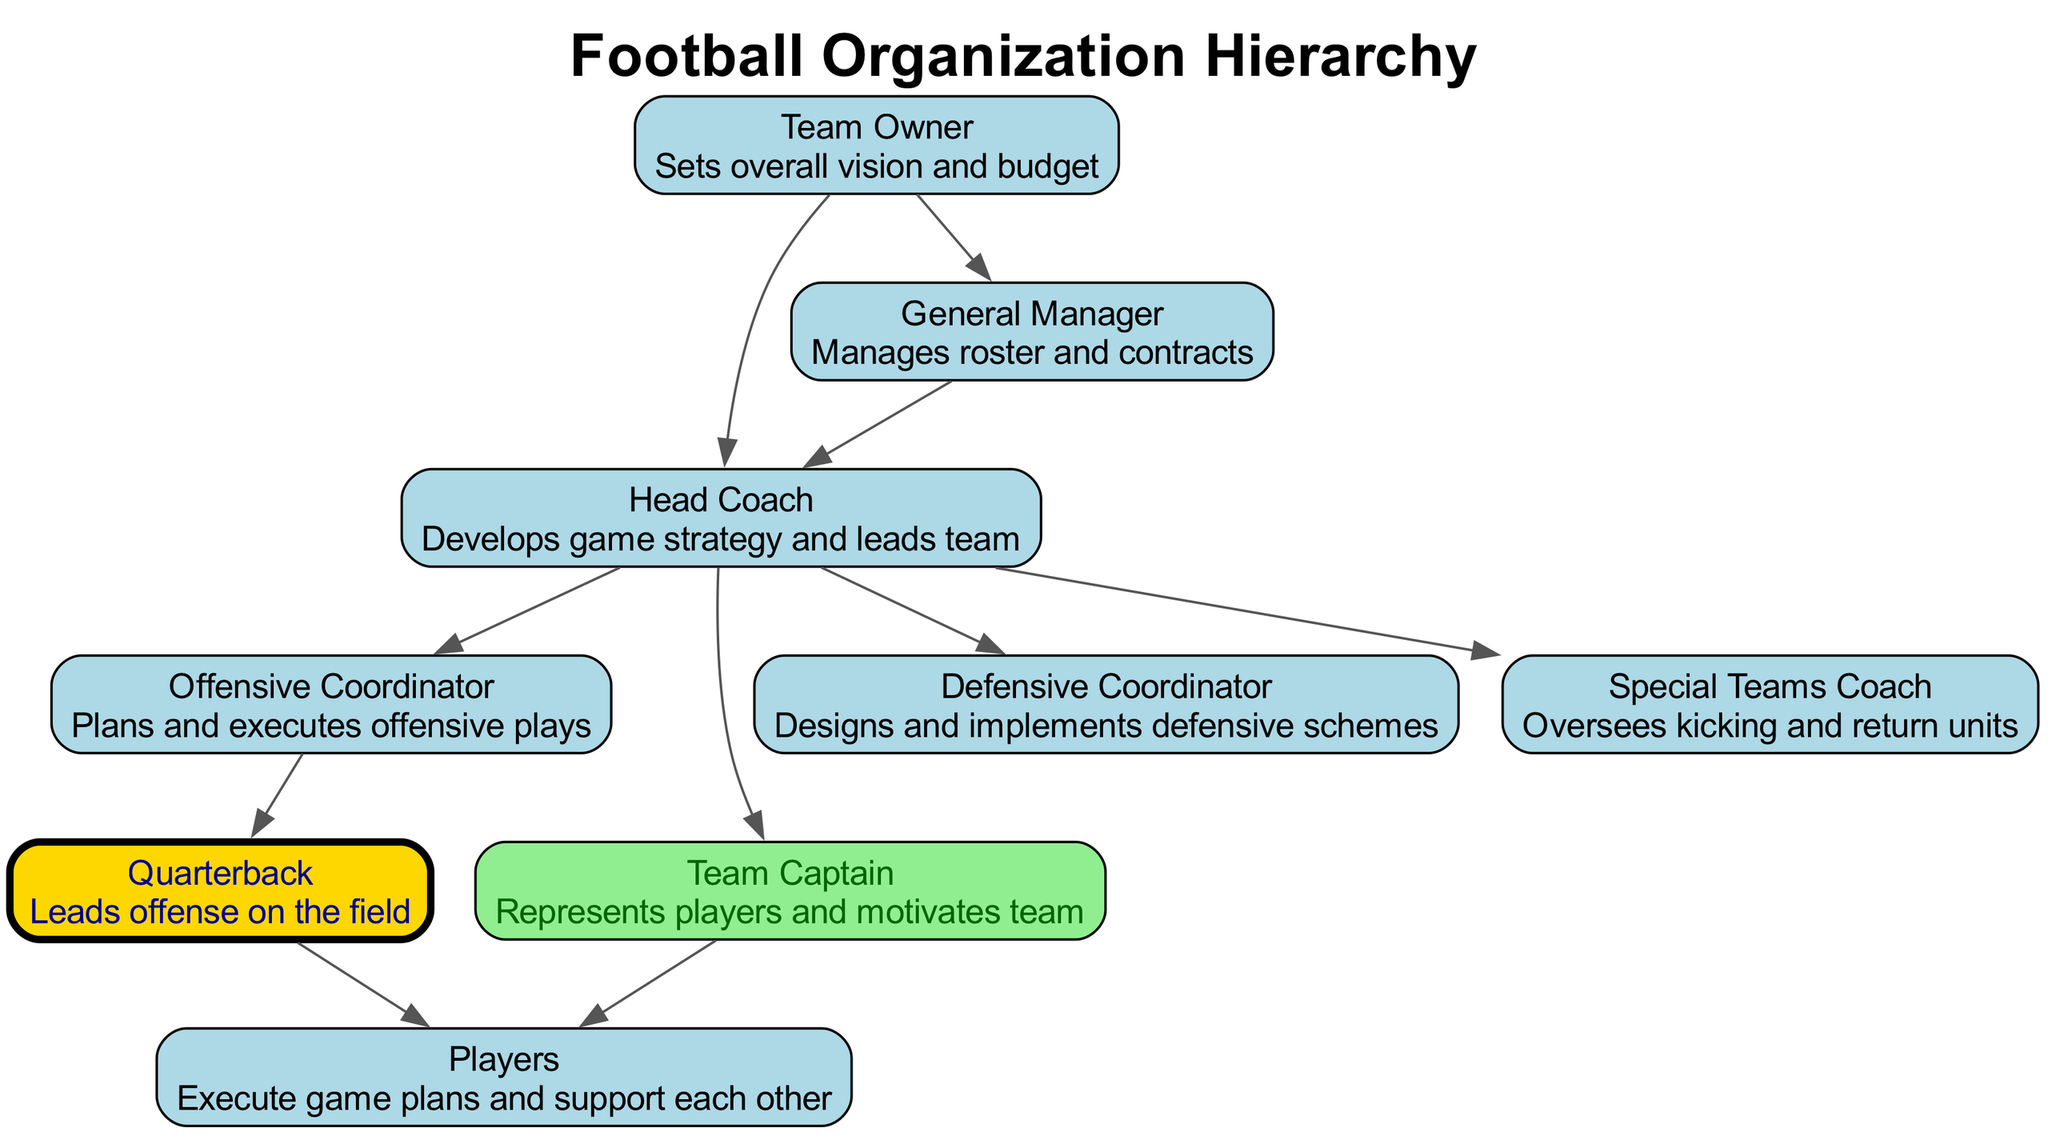What is the top role in the football organization? The top role is the "Team Owner," who sets the overall vision and budget for the organization. This can be found in the hierarchy chart at the highest level.
Answer: Team Owner How many edges are present in the diagram? To find the number of edges, count how many connections (lines) are drawn between the nodes in the hierarchy chart. There are a total of ten edges connecting various roles.
Answer: 10 Which role is responsible for developing game strategy? The "Head Coach" is responsible for developing the game's strategy and leading the team, which is explicitly stated in the node description.
Answer: Head Coach What role does the Quarterback report to? The "Quarterback" reports to the "Offensive Coordinator," as indicated by the directed edge connecting the two roles in the hierarchy.
Answer: Offensive Coordinator Who represents the players in the team? The "Team Captain" represents the players and motivates the team, as noted in the description of the Team Captain node.
Answer: Team Captain Which role is not directly above any other role in the hierarchy? The "Players" role is at the lowest level in the hierarchy, showing that they execute game plans and support each other, without any roles below them.
Answer: Players What is the relationship between the General Manager and the Head Coach? The "General Manager" manages the roster and contracts, and also oversees the "Head Coach," as depicted by the directed edge leading from the General Manager to the Head Coach role in the hierarchy chart.
Answer: Oversees What role leads the offense on the field? The "Quarterback" leads the offense on the field, which is directly mentioned in the node description for the Quarterback.
Answer: Quarterback Which role oversees kicking and return units? The "Special Teams Coach" oversees kicking and return units, as described in the corresponding node.
Answer: Special Teams Coach 